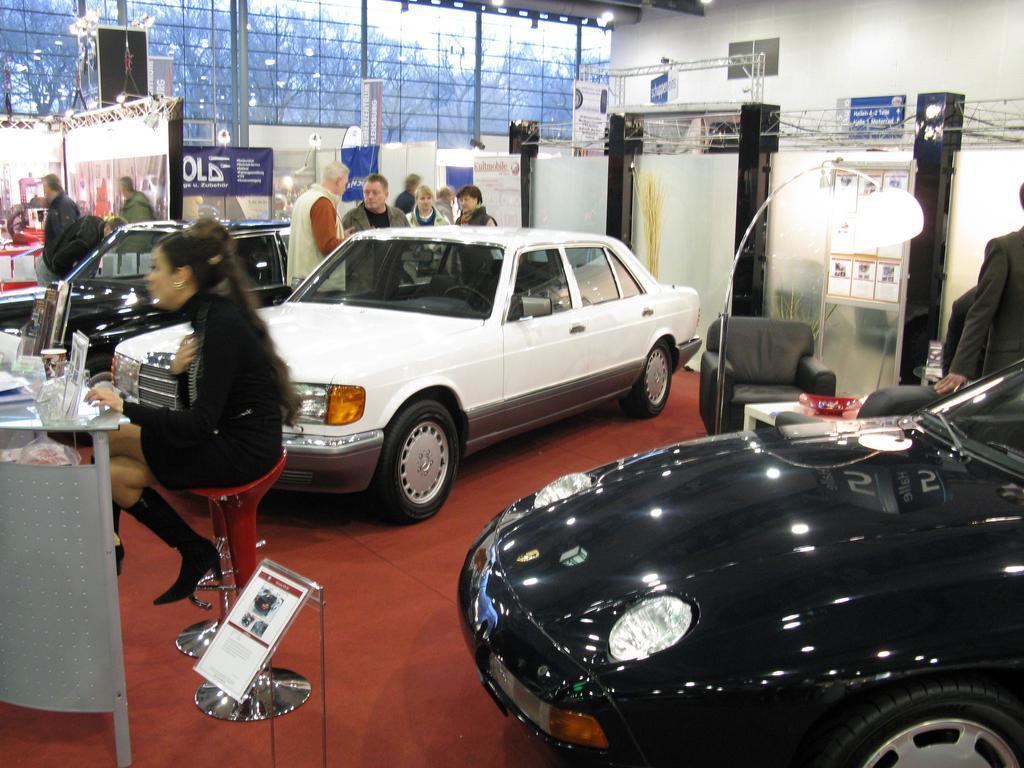Can you describe this image briefly? There is a red color car in the bottom right corner of this image. There is one woman sitting on a chair on the left side of this image, and there are two cars, and some persons are standing in the middle of this image,and there is a wall in the background. We can see a glass wall at the top of this image, and there is a couch on the right side of this image. 